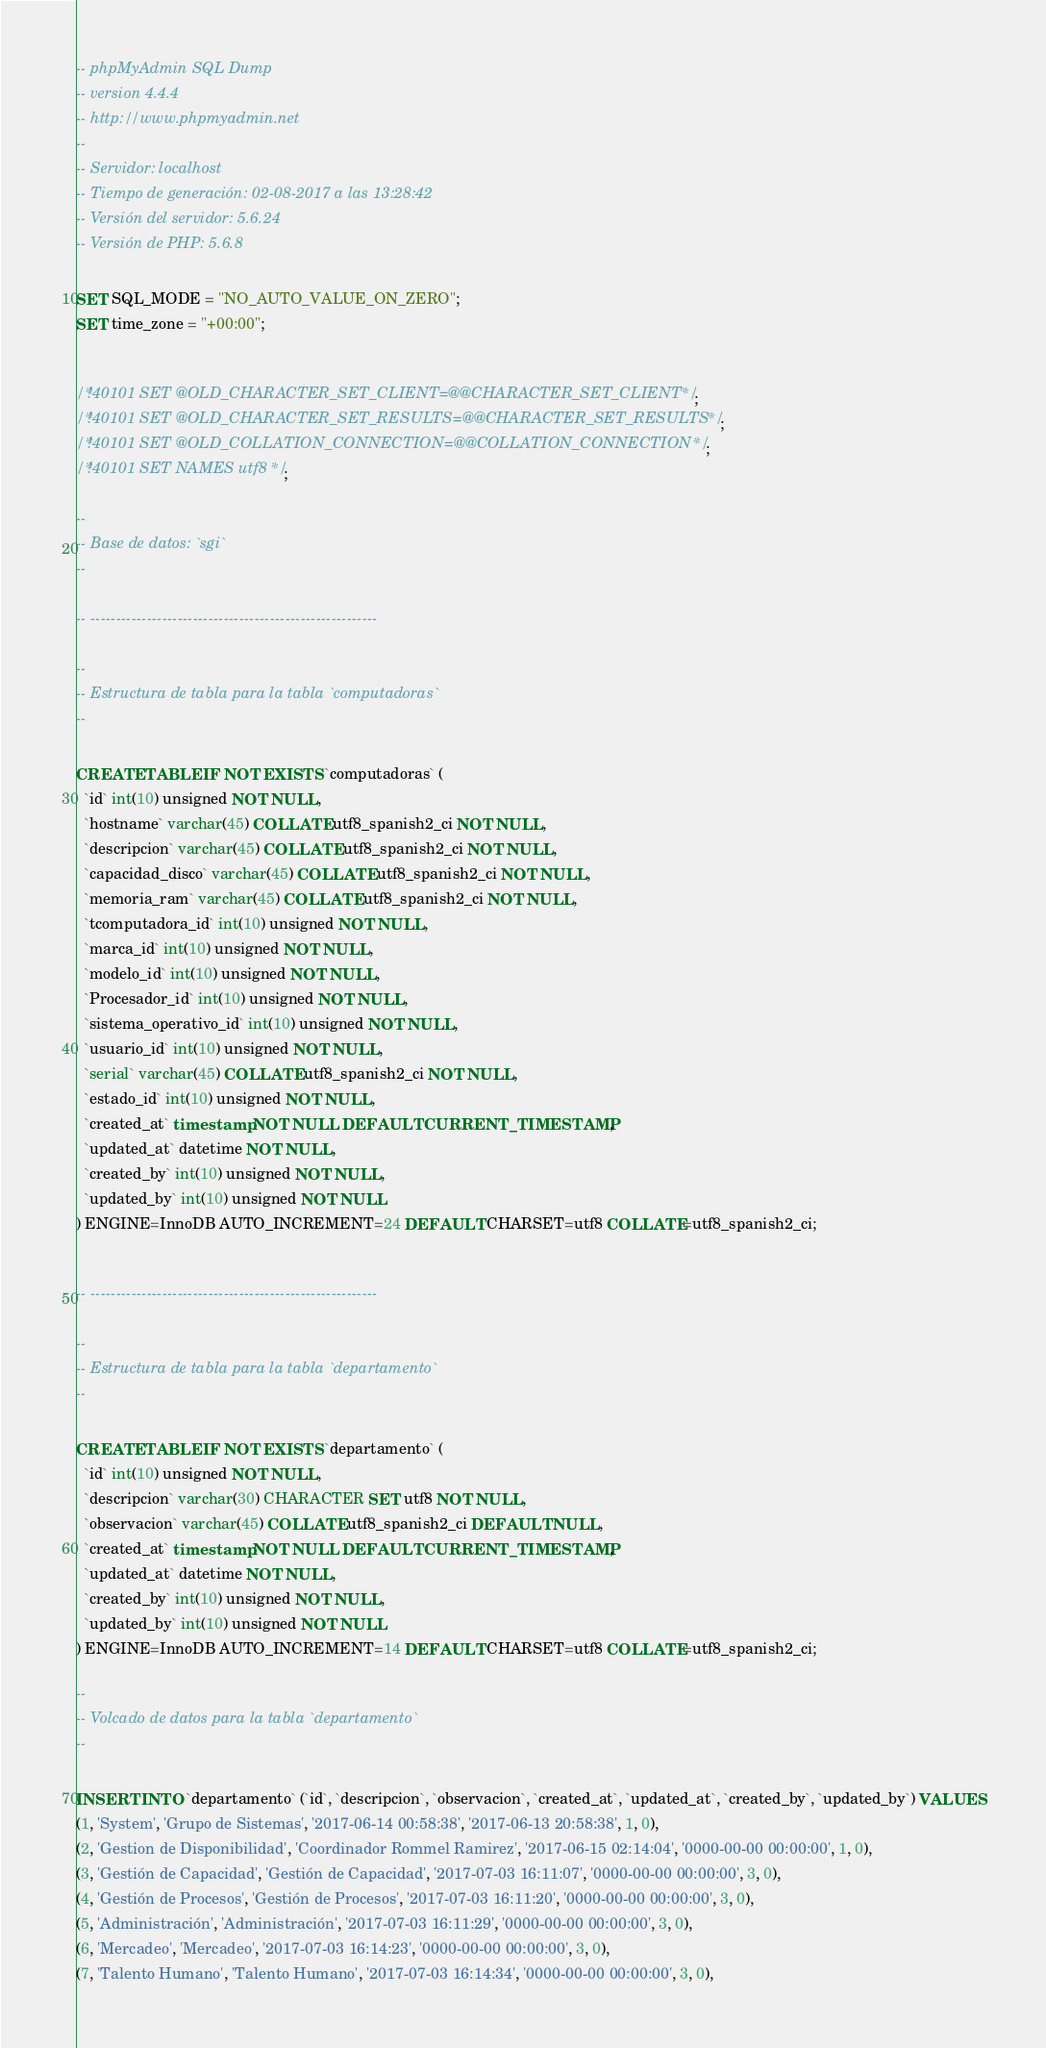Convert code to text. <code><loc_0><loc_0><loc_500><loc_500><_SQL_>-- phpMyAdmin SQL Dump
-- version 4.4.4
-- http://www.phpmyadmin.net
--
-- Servidor: localhost
-- Tiempo de generación: 02-08-2017 a las 13:28:42
-- Versión del servidor: 5.6.24
-- Versión de PHP: 5.6.8

SET SQL_MODE = "NO_AUTO_VALUE_ON_ZERO";
SET time_zone = "+00:00";


/*!40101 SET @OLD_CHARACTER_SET_CLIENT=@@CHARACTER_SET_CLIENT */;
/*!40101 SET @OLD_CHARACTER_SET_RESULTS=@@CHARACTER_SET_RESULTS */;
/*!40101 SET @OLD_COLLATION_CONNECTION=@@COLLATION_CONNECTION */;
/*!40101 SET NAMES utf8 */;

--
-- Base de datos: `sgi`
--

-- --------------------------------------------------------

--
-- Estructura de tabla para la tabla `computadoras`
--

CREATE TABLE IF NOT EXISTS `computadoras` (
  `id` int(10) unsigned NOT NULL,
  `hostname` varchar(45) COLLATE utf8_spanish2_ci NOT NULL,
  `descripcion` varchar(45) COLLATE utf8_spanish2_ci NOT NULL,
  `capacidad_disco` varchar(45) COLLATE utf8_spanish2_ci NOT NULL,
  `memoria_ram` varchar(45) COLLATE utf8_spanish2_ci NOT NULL,
  `tcomputadora_id` int(10) unsigned NOT NULL,
  `marca_id` int(10) unsigned NOT NULL,
  `modelo_id` int(10) unsigned NOT NULL,
  `Procesador_id` int(10) unsigned NOT NULL,
  `sistema_operativo_id` int(10) unsigned NOT NULL,
  `usuario_id` int(10) unsigned NOT NULL,
  `serial` varchar(45) COLLATE utf8_spanish2_ci NOT NULL,
  `estado_id` int(10) unsigned NOT NULL,
  `created_at` timestamp NOT NULL DEFAULT CURRENT_TIMESTAMP,
  `updated_at` datetime NOT NULL,
  `created_by` int(10) unsigned NOT NULL,
  `updated_by` int(10) unsigned NOT NULL
) ENGINE=InnoDB AUTO_INCREMENT=24 DEFAULT CHARSET=utf8 COLLATE=utf8_spanish2_ci;


-- --------------------------------------------------------

--
-- Estructura de tabla para la tabla `departamento`
--

CREATE TABLE IF NOT EXISTS `departamento` (
  `id` int(10) unsigned NOT NULL,
  `descripcion` varchar(30) CHARACTER SET utf8 NOT NULL,
  `observacion` varchar(45) COLLATE utf8_spanish2_ci DEFAULT NULL,
  `created_at` timestamp NOT NULL DEFAULT CURRENT_TIMESTAMP,
  `updated_at` datetime NOT NULL,
  `created_by` int(10) unsigned NOT NULL,
  `updated_by` int(10) unsigned NOT NULL
) ENGINE=InnoDB AUTO_INCREMENT=14 DEFAULT CHARSET=utf8 COLLATE=utf8_spanish2_ci;

--
-- Volcado de datos para la tabla `departamento`
--

INSERT INTO `departamento` (`id`, `descripcion`, `observacion`, `created_at`, `updated_at`, `created_by`, `updated_by`) VALUES
(1, 'System', 'Grupo de Sistemas', '2017-06-14 00:58:38', '2017-06-13 20:58:38', 1, 0),
(2, 'Gestion de Disponibilidad', 'Coordinador Rommel Ramirez', '2017-06-15 02:14:04', '0000-00-00 00:00:00', 1, 0),
(3, 'Gestión de Capacidad', 'Gestión de Capacidad', '2017-07-03 16:11:07', '0000-00-00 00:00:00', 3, 0),
(4, 'Gestión de Procesos', 'Gestión de Procesos', '2017-07-03 16:11:20', '0000-00-00 00:00:00', 3, 0),
(5, 'Administración', 'Administración', '2017-07-03 16:11:29', '0000-00-00 00:00:00', 3, 0),
(6, 'Mercadeo', 'Mercadeo', '2017-07-03 16:14:23', '0000-00-00 00:00:00', 3, 0),
(7, 'Talento Humano', 'Talento Humano', '2017-07-03 16:14:34', '0000-00-00 00:00:00', 3, 0),</code> 